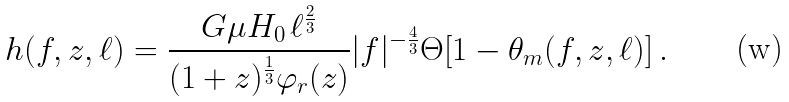<formula> <loc_0><loc_0><loc_500><loc_500>h ( f , z , \ell ) = \frac { G \mu H _ { 0 } \, \ell ^ { \frac { 2 } { 3 } } } { ( 1 + z ) ^ { \frac { 1 } { 3 } } \varphi _ { r } ( z ) } | f | ^ { - \frac { 4 } { 3 } } \Theta [ 1 - \theta _ { m } ( f , z , \ell ) ] \, .</formula> 